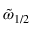<formula> <loc_0><loc_0><loc_500><loc_500>\tilde { \omega } _ { 1 / 2 }</formula> 